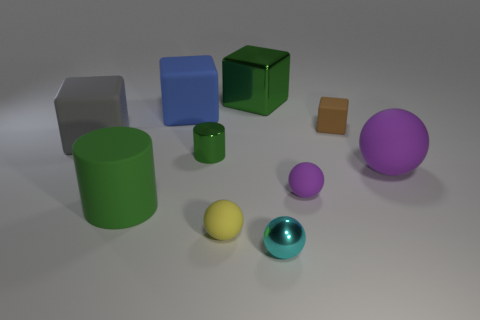Subtract all small cyan metal spheres. How many spheres are left? 3 Subtract all purple cubes. Subtract all purple balls. How many cubes are left? 4 Subtract all spheres. How many objects are left? 6 Subtract all red shiny things. Subtract all large matte cylinders. How many objects are left? 9 Add 3 yellow rubber spheres. How many yellow rubber spheres are left? 4 Add 1 tiny red balls. How many tiny red balls exist? 1 Subtract 0 yellow cylinders. How many objects are left? 10 